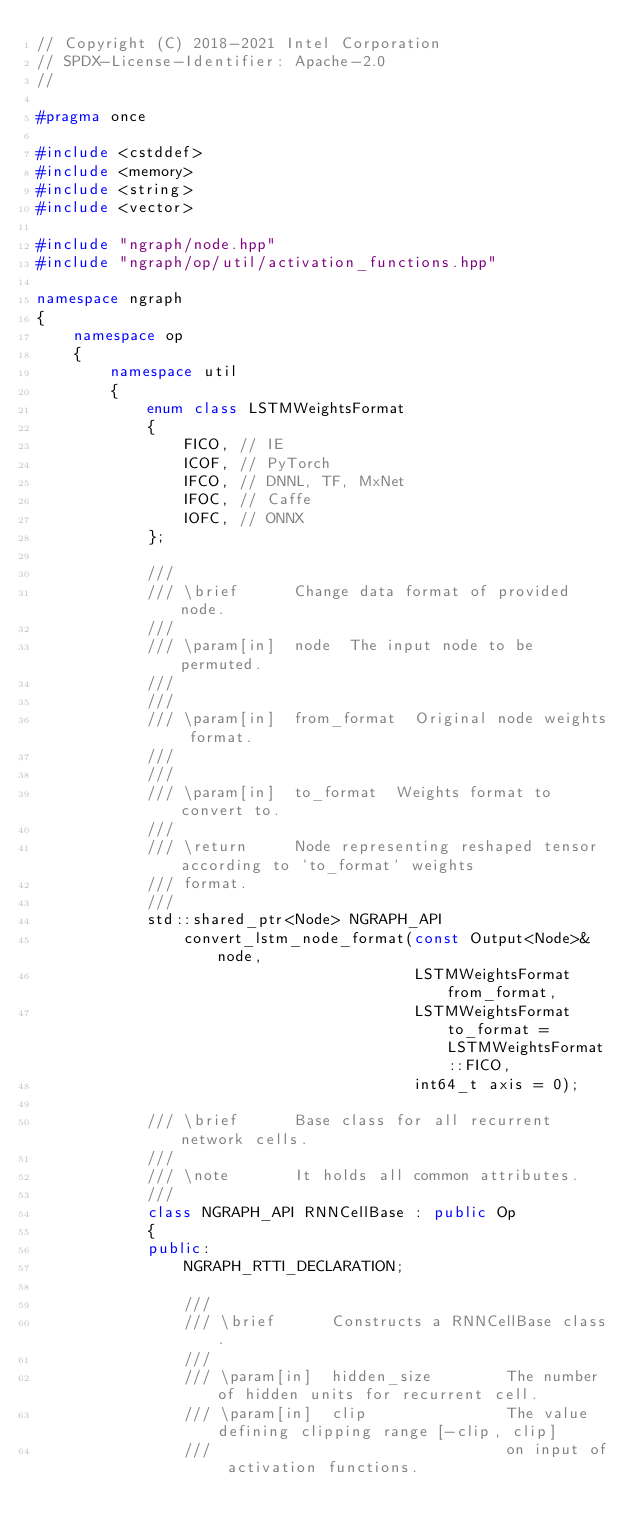<code> <loc_0><loc_0><loc_500><loc_500><_C++_>// Copyright (C) 2018-2021 Intel Corporation
// SPDX-License-Identifier: Apache-2.0
//

#pragma once

#include <cstddef>
#include <memory>
#include <string>
#include <vector>

#include "ngraph/node.hpp"
#include "ngraph/op/util/activation_functions.hpp"

namespace ngraph
{
    namespace op
    {
        namespace util
        {
            enum class LSTMWeightsFormat
            {
                FICO, // IE
                ICOF, // PyTorch
                IFCO, // DNNL, TF, MxNet
                IFOC, // Caffe
                IOFC, // ONNX
            };

            ///
            /// \brief      Change data format of provided node.
            ///
            /// \param[in]  node  The input node to be permuted.
            ///
            ///
            /// \param[in]  from_format  Original node weights format.
            ///
            ///
            /// \param[in]  to_format  Weights format to convert to.
            ///
            /// \return     Node representing reshaped tensor according to `to_format` weights
            /// format.
            ///
            std::shared_ptr<Node> NGRAPH_API
                convert_lstm_node_format(const Output<Node>& node,
                                         LSTMWeightsFormat from_format,
                                         LSTMWeightsFormat to_format = LSTMWeightsFormat::FICO,
                                         int64_t axis = 0);

            /// \brief      Base class for all recurrent network cells.
            ///
            /// \note       It holds all common attributes.
            ///
            class NGRAPH_API RNNCellBase : public Op
            {
            public:
                NGRAPH_RTTI_DECLARATION;

                ///
                /// \brief      Constructs a RNNCellBase class.
                ///
                /// \param[in]  hidden_size        The number of hidden units for recurrent cell.
                /// \param[in]  clip               The value defining clipping range [-clip, clip]
                ///                                on input of activation functions.</code> 